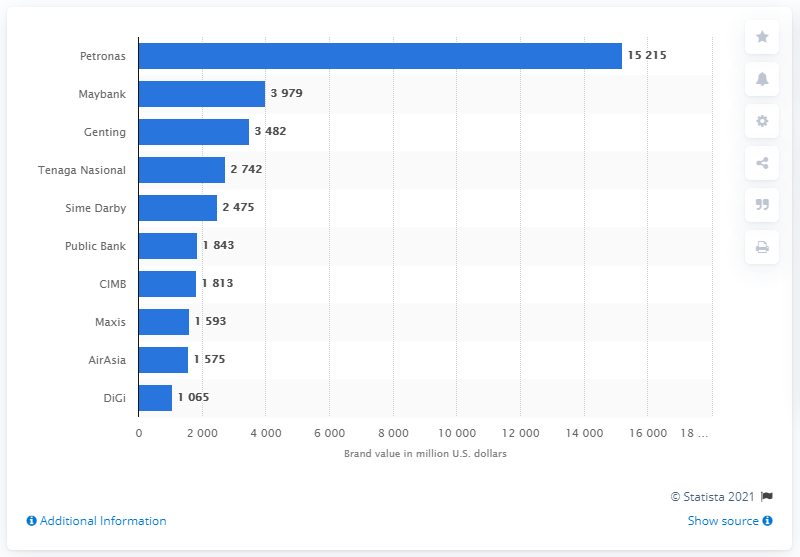What is the second most valuable Malaysian brand?
 Maybank 